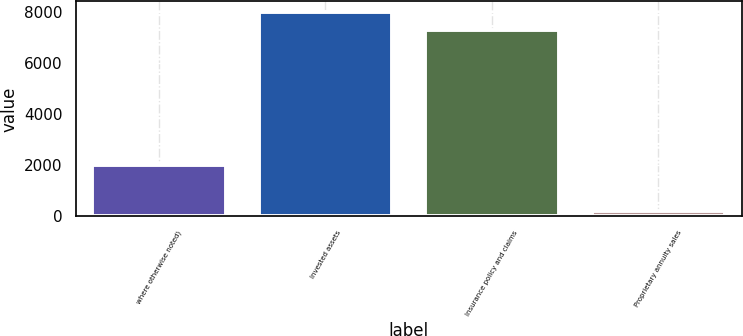Convert chart. <chart><loc_0><loc_0><loc_500><loc_500><bar_chart><fcel>where otherwise noted)<fcel>Invested assets<fcel>Insurance policy and claims<fcel>Proprietary annuity sales<nl><fcel>2004<fcel>7995<fcel>7279<fcel>208<nl></chart> 